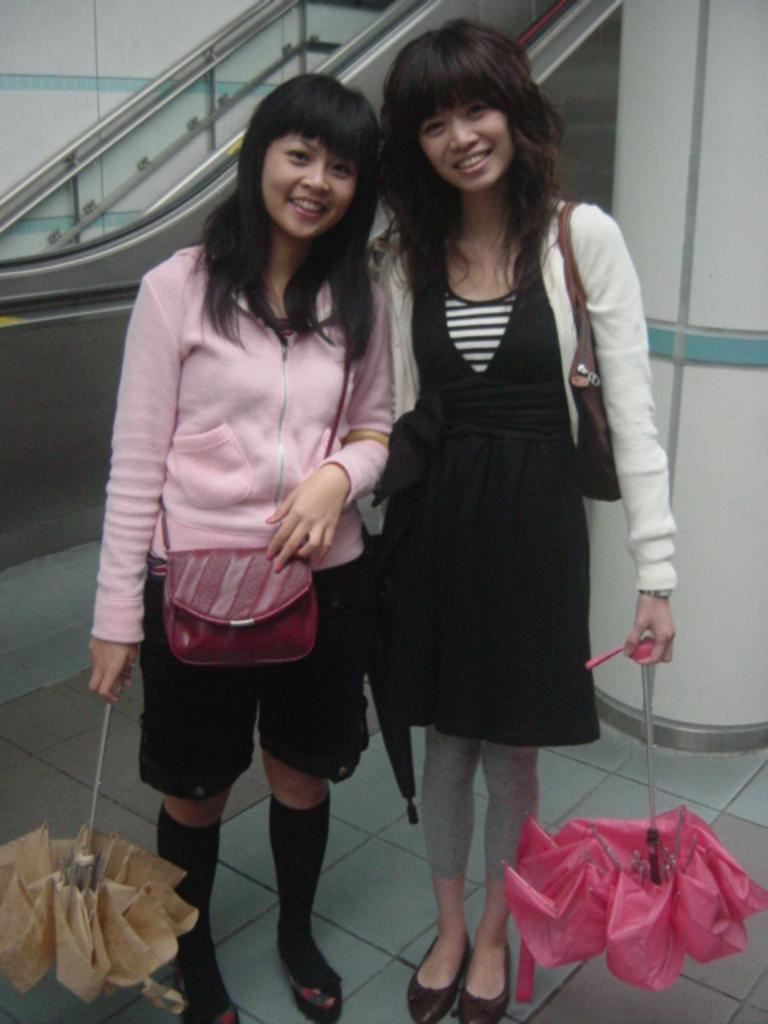How many women are in the image? There are two women in the image. What are the women carrying in their hands? The women are carrying handbags and holding umbrellas. What can be seen in the background of the image? There is an escalator and a wall in the background of the image. What type of veil is covering the escalator in the image? There is no veil present in the image, and the escalator is not covered. 